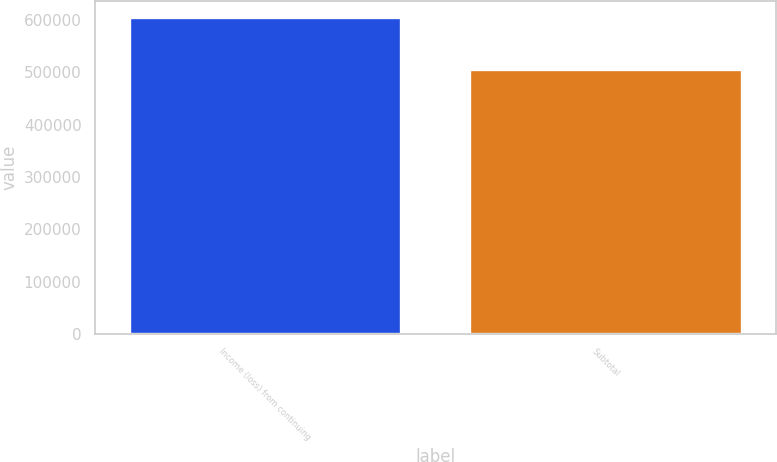<chart> <loc_0><loc_0><loc_500><loc_500><bar_chart><fcel>Income (loss) from continuing<fcel>Subtotal<nl><fcel>605690<fcel>506206<nl></chart> 